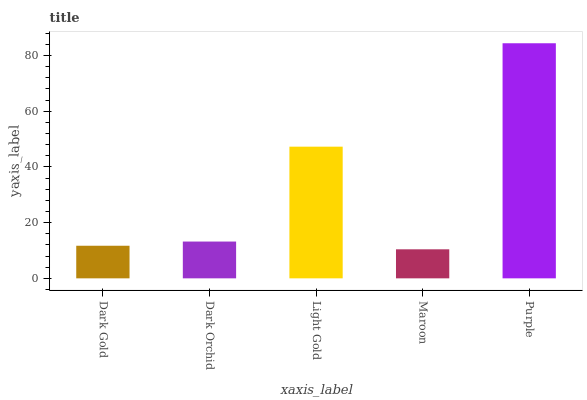Is Dark Orchid the minimum?
Answer yes or no. No. Is Dark Orchid the maximum?
Answer yes or no. No. Is Dark Orchid greater than Dark Gold?
Answer yes or no. Yes. Is Dark Gold less than Dark Orchid?
Answer yes or no. Yes. Is Dark Gold greater than Dark Orchid?
Answer yes or no. No. Is Dark Orchid less than Dark Gold?
Answer yes or no. No. Is Dark Orchid the high median?
Answer yes or no. Yes. Is Dark Orchid the low median?
Answer yes or no. Yes. Is Dark Gold the high median?
Answer yes or no. No. Is Maroon the low median?
Answer yes or no. No. 